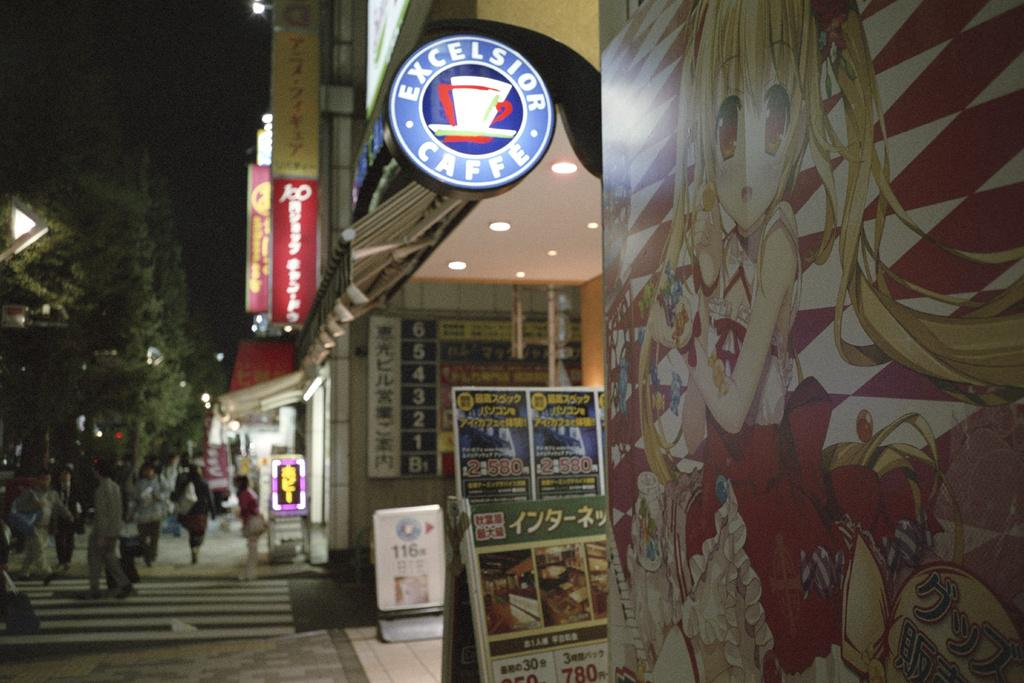<image>
Render a clear and concise summary of the photo. A coffe shop with a sign showing it is called Excelsior Caffe. 